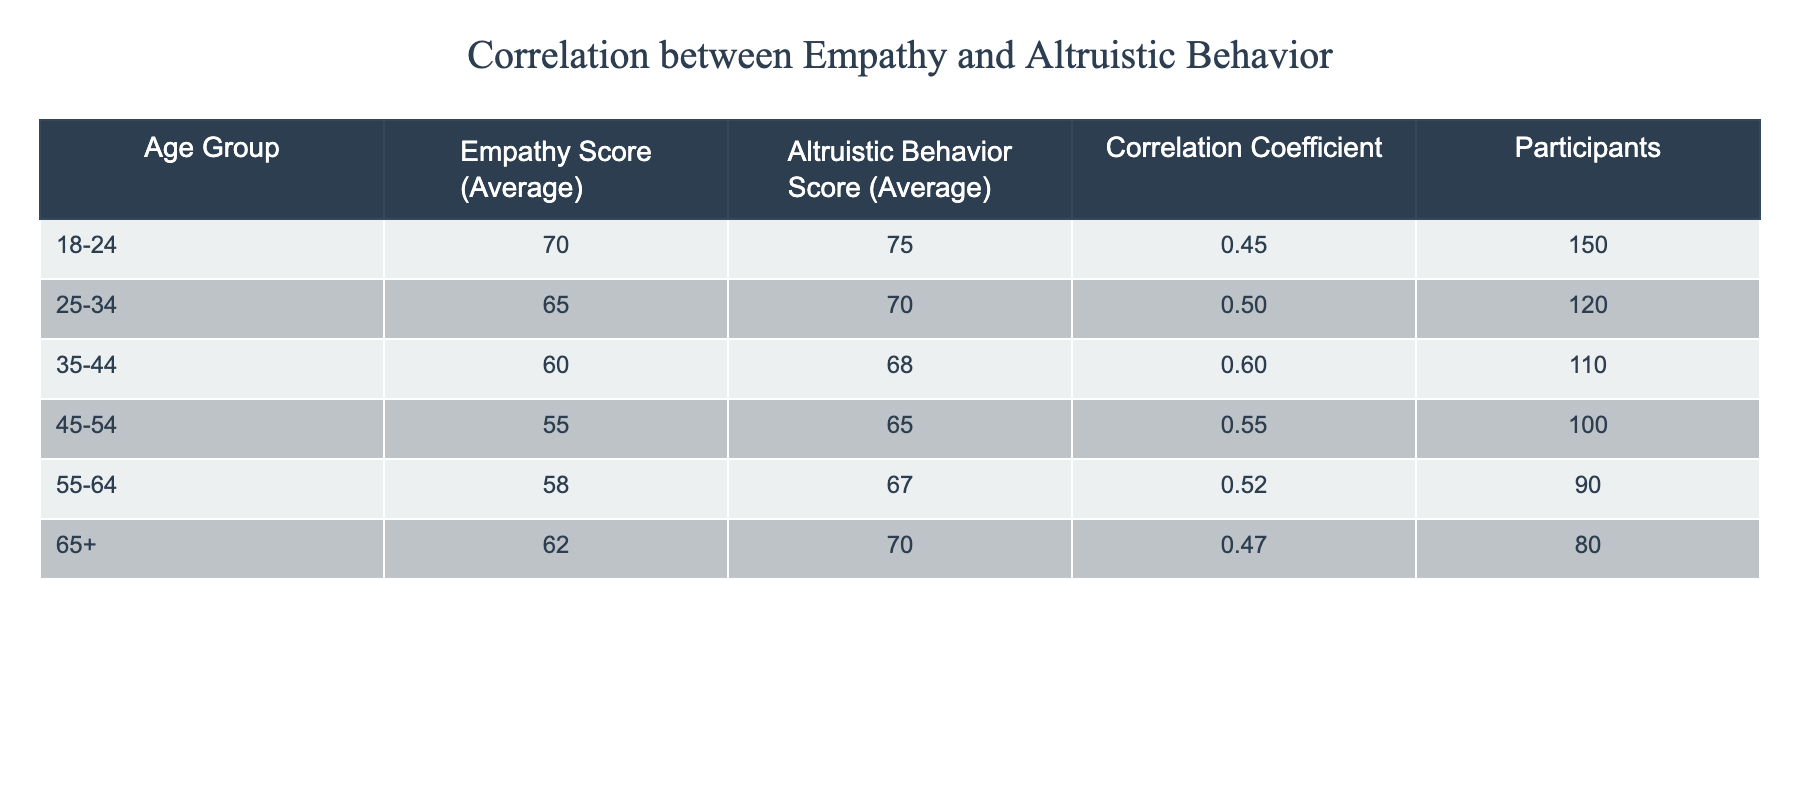What is the average empathy score for participants aged 18-24? The empathy score for the 18-24 age group is explicitly provided in the table as 70.
Answer: 70 What is the correlation coefficient for the 45-54 age group? The correlation coefficient for the 45-54 age group is directly stated in the table, which is 0.55.
Answer: 0.55 Which age group has the highest average altruistic behavior score? By examining the altruistic behavior scores in the table, the 18-24 age group has the highest score of 75 compared to other age groups.
Answer: 18-24 Is the correlation coefficient for the 35-44 age group greater than that of the 25-34 age group? The correlation coefficient for the 35-44 age group is 0.60, while for the 25-34 age group it is 0.50. Since 0.60 > 0.50, the statement is true.
Answer: Yes What is the difference between the average altruistic behavior scores of the 55-64 and 25-34 age groups? The average altruistic behavior score for the 55-64 age group is 67, and for the 25-34 age group it is 70. The difference is 70 - 67 = 3.
Answer: 3 If we average the empathy scores across all age groups, what is the result? To find the average empathy score across all age groups, we sum the empathy scores: 70 + 65 + 60 + 55 + 58 + 62 = 400. There are 6 age groups, so the average is 400 / 6 = approximately 66.67.
Answer: 66.67 Which age group displays the lowest average empathy score? By inspecting the empathy scores, the 45-54 age group shows the lowest score at 55, making it the group with the least empathy on average.
Answer: 45-54 What is the total number of participants from the age group 65 and older? According to the table, there are 80 participants in the age group 65 and older, as listed directly in the data.
Answer: 80 Is there any age group with a correlation coefficient below 0.5? The table indicates that the 18-24 and 25-34 groups have correlation coefficients (0.45 and 0.50, respectively) below 0.5, confirming this statement is true.
Answer: Yes 